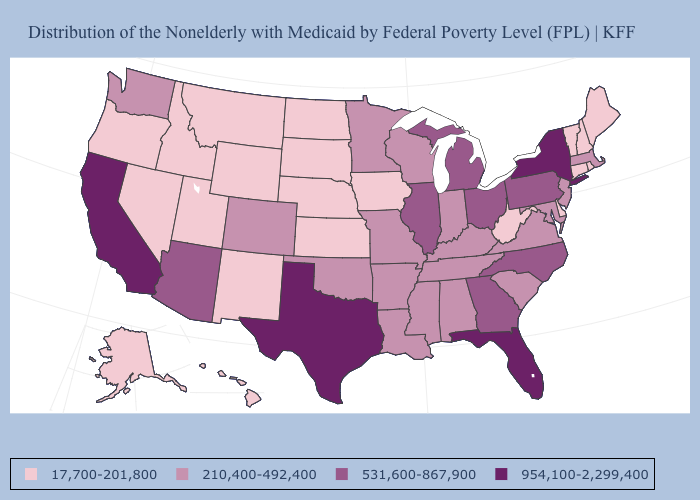What is the highest value in states that border Maryland?
Be succinct. 531,600-867,900. What is the lowest value in states that border Oklahoma?
Be succinct. 17,700-201,800. What is the value of Michigan?
Quick response, please. 531,600-867,900. What is the value of Minnesota?
Be succinct. 210,400-492,400. Which states have the lowest value in the USA?
Concise answer only. Alaska, Connecticut, Delaware, Hawaii, Idaho, Iowa, Kansas, Maine, Montana, Nebraska, Nevada, New Hampshire, New Mexico, North Dakota, Oregon, Rhode Island, South Dakota, Utah, Vermont, West Virginia, Wyoming. What is the lowest value in the Northeast?
Answer briefly. 17,700-201,800. What is the lowest value in states that border Massachusetts?
Short answer required. 17,700-201,800. Which states have the lowest value in the USA?
Quick response, please. Alaska, Connecticut, Delaware, Hawaii, Idaho, Iowa, Kansas, Maine, Montana, Nebraska, Nevada, New Hampshire, New Mexico, North Dakota, Oregon, Rhode Island, South Dakota, Utah, Vermont, West Virginia, Wyoming. Name the states that have a value in the range 17,700-201,800?
Give a very brief answer. Alaska, Connecticut, Delaware, Hawaii, Idaho, Iowa, Kansas, Maine, Montana, Nebraska, Nevada, New Hampshire, New Mexico, North Dakota, Oregon, Rhode Island, South Dakota, Utah, Vermont, West Virginia, Wyoming. Which states have the lowest value in the West?
Give a very brief answer. Alaska, Hawaii, Idaho, Montana, Nevada, New Mexico, Oregon, Utah, Wyoming. Which states have the lowest value in the West?
Give a very brief answer. Alaska, Hawaii, Idaho, Montana, Nevada, New Mexico, Oregon, Utah, Wyoming. Does Arizona have the lowest value in the USA?
Keep it brief. No. What is the value of Nebraska?
Be succinct. 17,700-201,800. Does the map have missing data?
Answer briefly. No. 